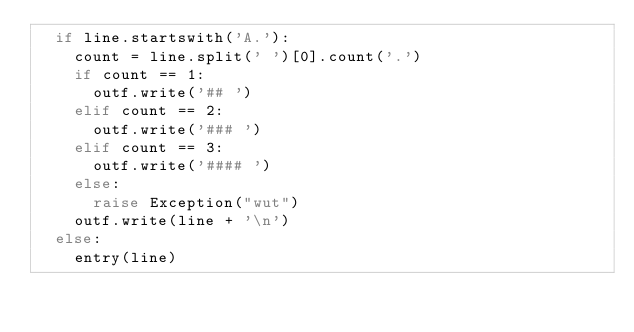<code> <loc_0><loc_0><loc_500><loc_500><_Python_>	if line.startswith('A.'):
		count = line.split(' ')[0].count('.')
		if count == 1:
			outf.write('## ')
		elif count == 2:
			outf.write('### ')
		elif count == 3:
			outf.write('#### ')
		else:
			raise Exception("wut")
		outf.write(line + '\n')
	else:
		entry(line)
</code> 